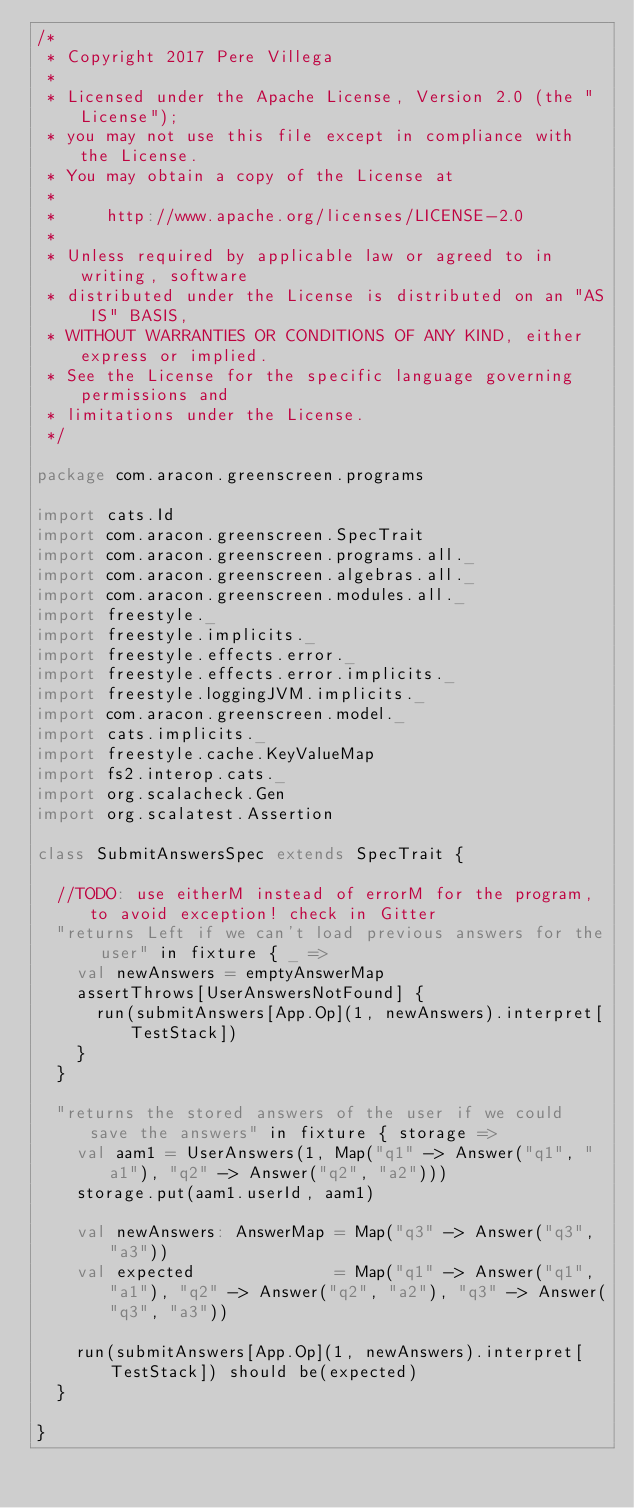Convert code to text. <code><loc_0><loc_0><loc_500><loc_500><_Scala_>/*
 * Copyright 2017 Pere Villega
 *
 * Licensed under the Apache License, Version 2.0 (the "License");
 * you may not use this file except in compliance with the License.
 * You may obtain a copy of the License at
 *
 *     http://www.apache.org/licenses/LICENSE-2.0
 *
 * Unless required by applicable law or agreed to in writing, software
 * distributed under the License is distributed on an "AS IS" BASIS,
 * WITHOUT WARRANTIES OR CONDITIONS OF ANY KIND, either express or implied.
 * See the License for the specific language governing permissions and
 * limitations under the License.
 */

package com.aracon.greenscreen.programs

import cats.Id
import com.aracon.greenscreen.SpecTrait
import com.aracon.greenscreen.programs.all._
import com.aracon.greenscreen.algebras.all._
import com.aracon.greenscreen.modules.all._
import freestyle._
import freestyle.implicits._
import freestyle.effects.error._
import freestyle.effects.error.implicits._
import freestyle.loggingJVM.implicits._
import com.aracon.greenscreen.model._
import cats.implicits._
import freestyle.cache.KeyValueMap
import fs2.interop.cats._
import org.scalacheck.Gen
import org.scalatest.Assertion

class SubmitAnswersSpec extends SpecTrait {

  //TODO: use eitherM instead of errorM for the program, to avoid exception! check in Gitter
  "returns Left if we can't load previous answers for the user" in fixture { _ =>
    val newAnswers = emptyAnswerMap
    assertThrows[UserAnswersNotFound] {
      run(submitAnswers[App.Op](1, newAnswers).interpret[TestStack])
    }
  }

  "returns the stored answers of the user if we could save the answers" in fixture { storage =>
    val aam1 = UserAnswers(1, Map("q1" -> Answer("q1", "a1"), "q2" -> Answer("q2", "a2")))
    storage.put(aam1.userId, aam1)

    val newAnswers: AnswerMap = Map("q3" -> Answer("q3", "a3"))
    val expected              = Map("q1" -> Answer("q1", "a1"), "q2" -> Answer("q2", "a2"), "q3" -> Answer("q3", "a3"))

    run(submitAnswers[App.Op](1, newAnswers).interpret[TestStack]) should be(expected)
  }

}
</code> 